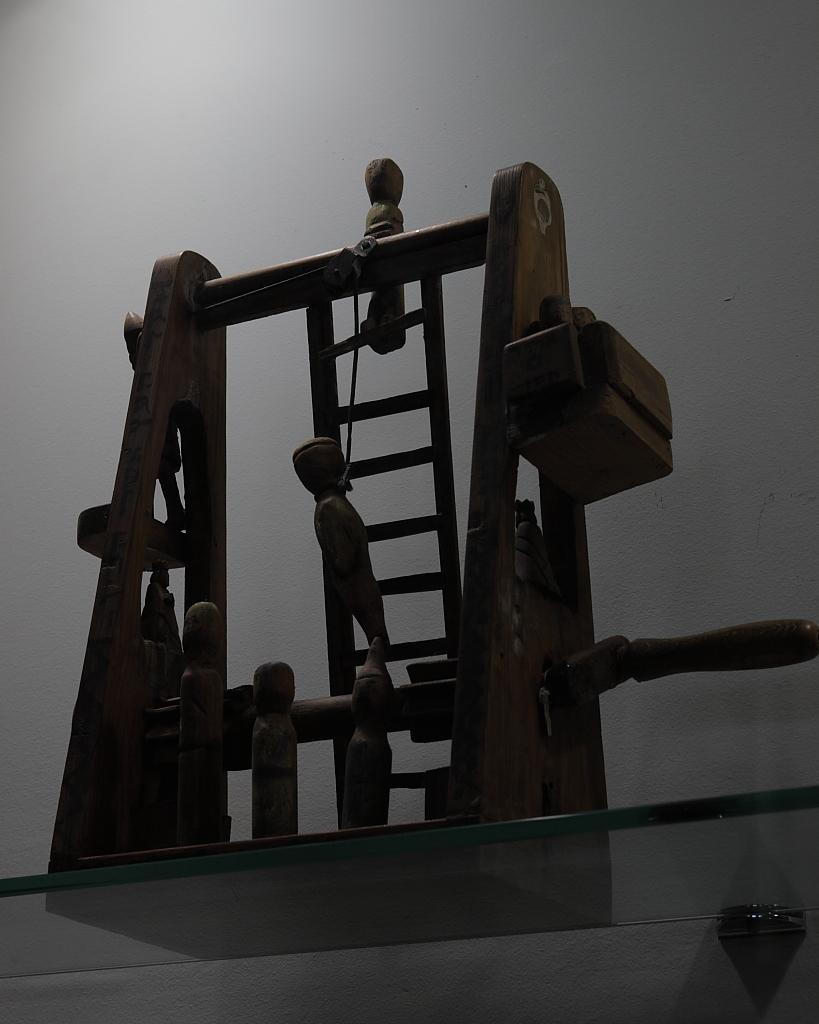What is the main object in the image? There is a wooden object in the image. What color is the background of the image? The background of the image is white. What type of patch is being tested on the wooden object in the image? There is no patch or testing activity depicted in the image; it only shows a wooden object with a white background. 